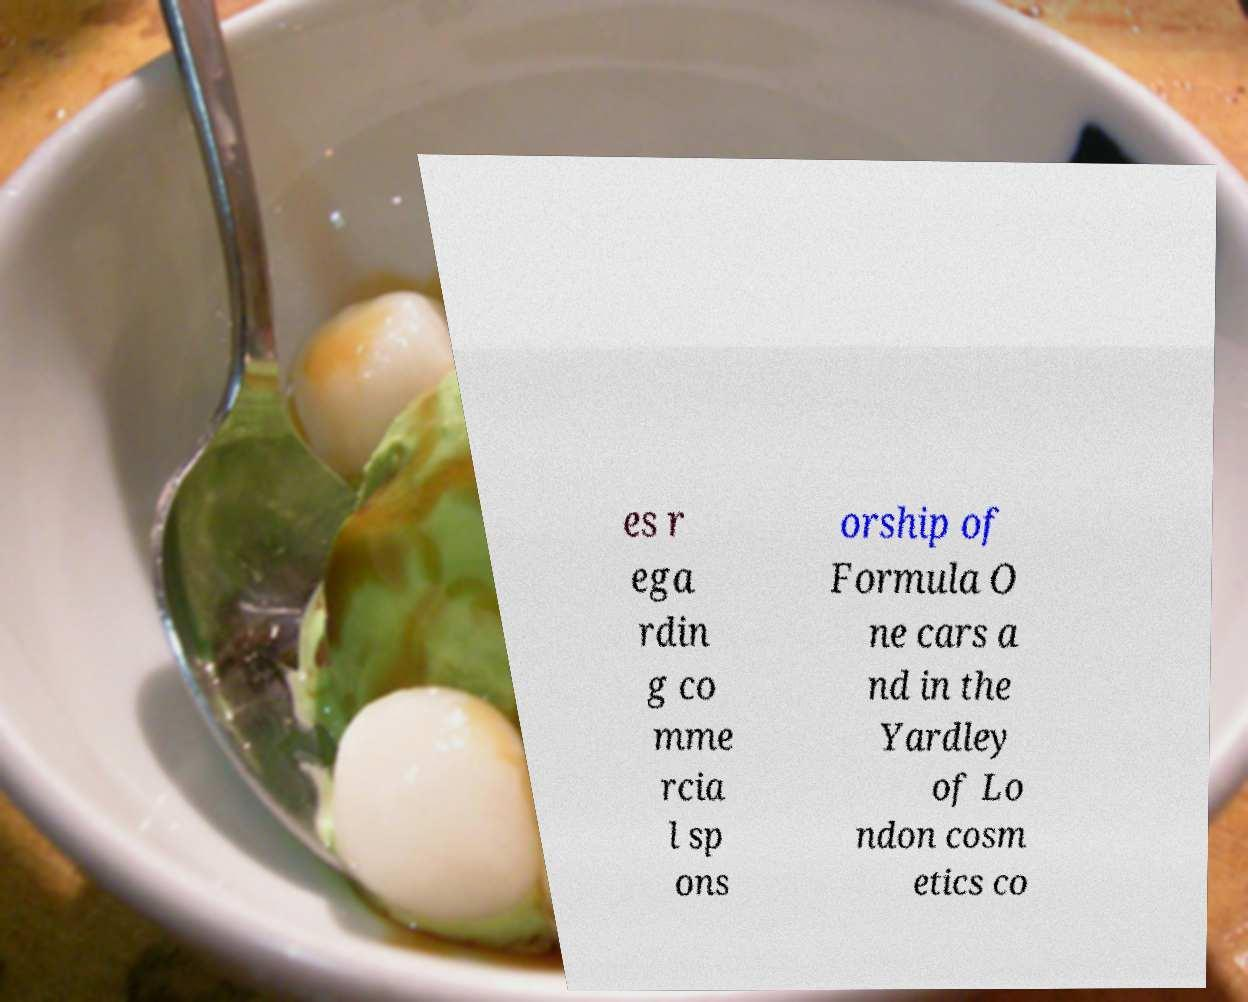What messages or text are displayed in this image? I need them in a readable, typed format. es r ega rdin g co mme rcia l sp ons orship of Formula O ne cars a nd in the Yardley of Lo ndon cosm etics co 